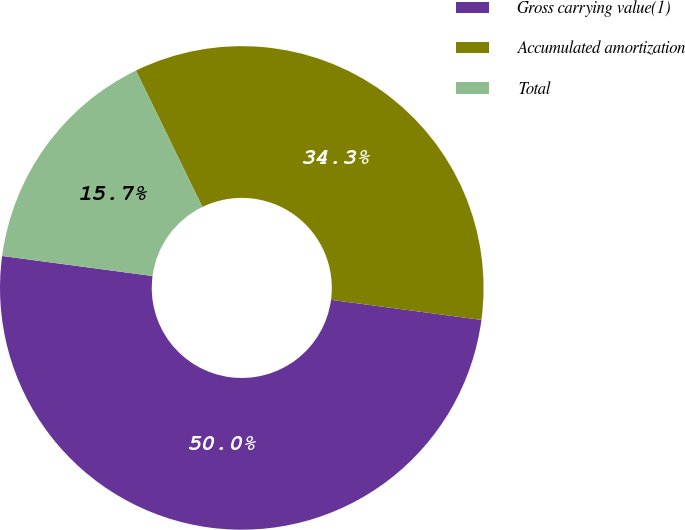Convert chart. <chart><loc_0><loc_0><loc_500><loc_500><pie_chart><fcel>Gross carrying value(1)<fcel>Accumulated amortization<fcel>Total<nl><fcel>50.0%<fcel>34.32%<fcel>15.68%<nl></chart> 